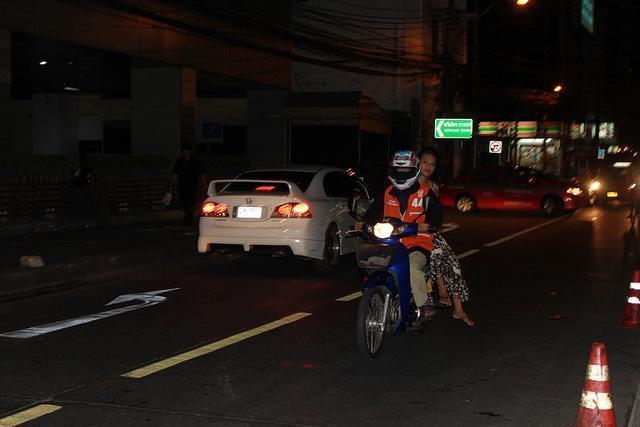How many people are there?
Give a very brief answer. 2. How many cars are there?
Give a very brief answer. 2. 